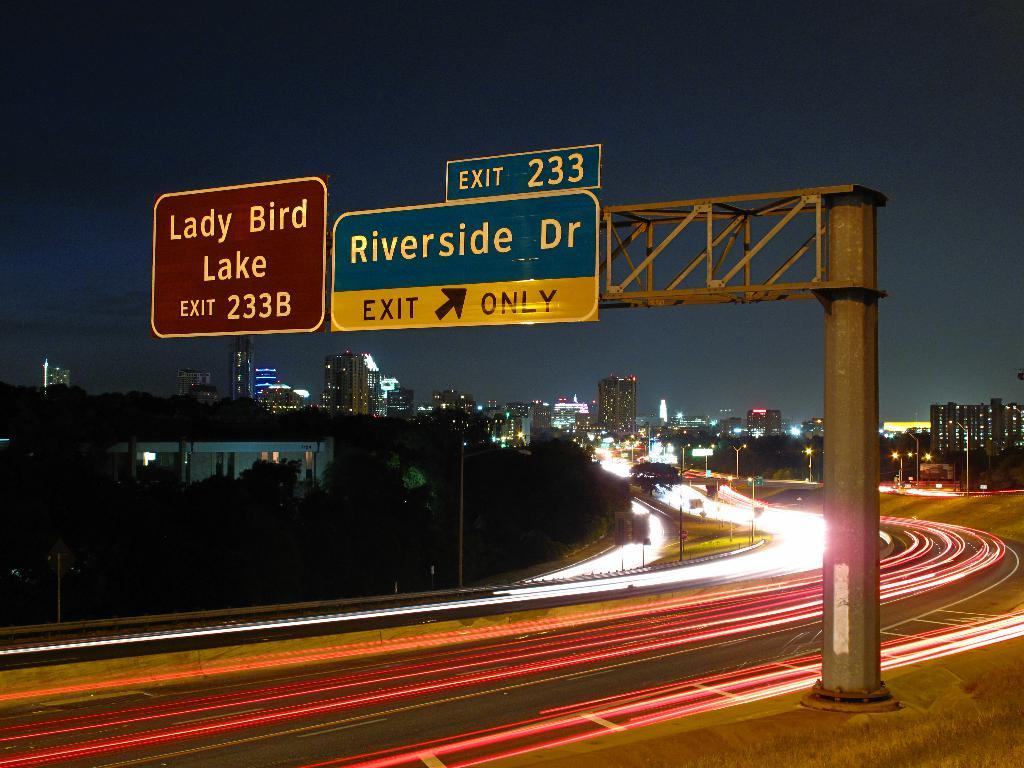<image>
Give a short and clear explanation of the subsequent image. A timelapse of a freeway with cars shown just as trails of lights, with a large exit sign to Riverside Drive 